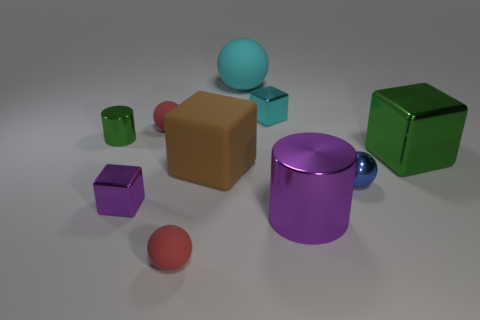There is a thing that is the same color as the tiny shiny cylinder; what is it made of?
Your answer should be very brief. Metal. Do the brown thing and the shiny cylinder that is right of the small cyan thing have the same size?
Offer a terse response. Yes. How big is the purple thing on the right side of the large matte thing that is in front of the large sphere?
Offer a terse response. Large. There is a large metal object that is the same shape as the small purple object; what is its color?
Ensure brevity in your answer.  Green. Is the blue object the same size as the matte cube?
Offer a terse response. No. Are there an equal number of large cyan matte spheres left of the small purple metal cube and large cyan shiny blocks?
Provide a short and direct response. Yes. Are there any objects on the left side of the purple shiny thing on the right side of the small purple metal block?
Give a very brief answer. Yes. How big is the purple thing on the left side of the tiny rubber thing that is in front of the purple object that is to the right of the big cyan object?
Give a very brief answer. Small. What material is the big thing that is in front of the tiny sphere to the right of the large ball?
Offer a terse response. Metal. Is there a brown matte thing of the same shape as the tiny purple metallic object?
Ensure brevity in your answer.  Yes. 